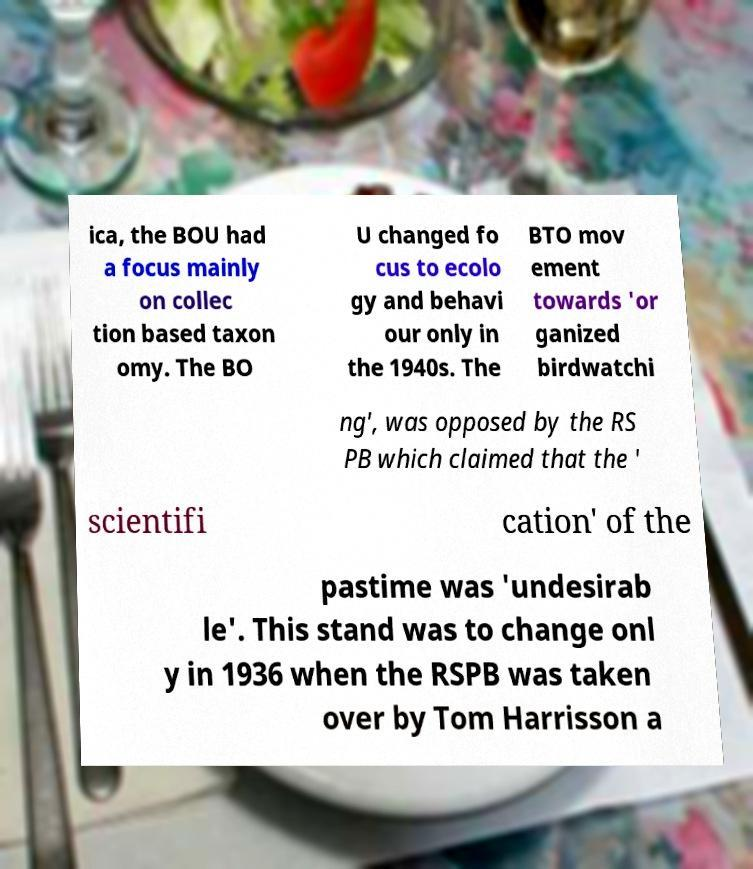I need the written content from this picture converted into text. Can you do that? ica, the BOU had a focus mainly on collec tion based taxon omy. The BO U changed fo cus to ecolo gy and behavi our only in the 1940s. The BTO mov ement towards 'or ganized birdwatchi ng', was opposed by the RS PB which claimed that the ' scientifi cation' of the pastime was 'undesirab le'. This stand was to change onl y in 1936 when the RSPB was taken over by Tom Harrisson a 